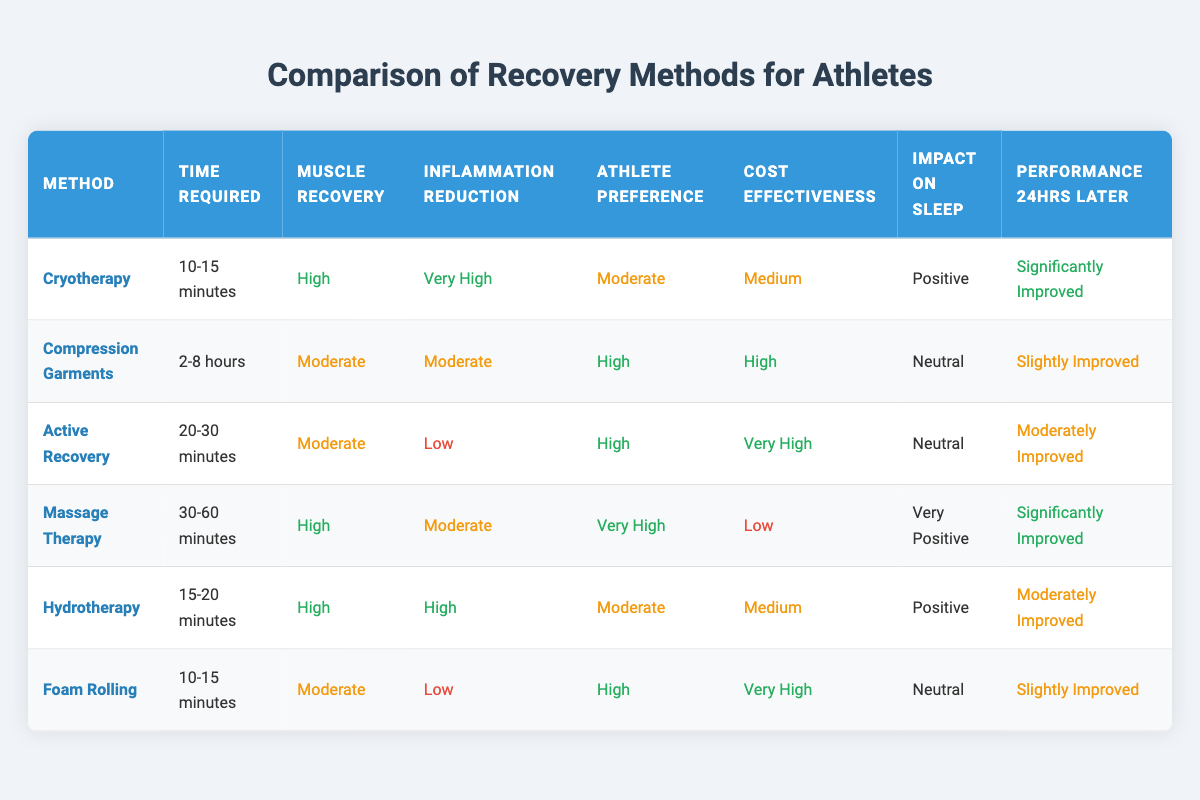What is the time required for Cryotherapy? The table shows the time required for each recovery method in the second column. For Cryotherapy, it states that the time required is "10-15 minutes."
Answer: 10-15 minutes Which recovery method has the highest inflammation reduction? By examining the table, we can see that Cryotherapy has "Very High" listed for inflammation reduction, while no other method surpasses this value.
Answer: Cryotherapy How many recovery methods have a "High" rating for muscle recovery? From the table, both Cryotherapy and Massage Therapy are marked as "High" for muscle recovery. Thus, there are two methods with this rating.
Answer: 2 Is Massage Therapy preferred by athletes? In the table, the athlete preference for Massage Therapy is labeled as "Very High," indicating that athletes do prefer this recovery method.
Answer: Yes Which recovery method provides a slight improvement in performance 24 hours later? The table indicates that Compression Garments and Foam Rolling both yield a "Slightly Improved" performance 24 hours later, confirming that they are the methods associated with this level of improvement.
Answer: Compression Garments and Foam Rolling What is the average time required for all the recovery methods listed? First, we identify the time required in total minutes: Cryotherapy is 12.5 minutes (average of 10-15), Compression Garments (300) minutes, Active Recovery (25 minutes), Massage Therapy (45 minutes), Hydrotherapy (17.5 minutes), and Foam Rolling (12.5 minutes). The overall sum is 12.5 + 300 + 25 + 45 + 17.5 + 12.5 = 412.5 minutes. Dividing by 6 recovery methods gives us an average of 68.75 minutes.
Answer: 68.75 minutes Which method has a "High" cost-effectiveness rating but only a "Moderate" inflammation reduction? The table shows that Compression Garments have a "High" cost-effectiveness rating and "Moderate" for inflammation reduction.
Answer: Compression Garments How does the impact on sleep compare between Massage Therapy and Hydrotherapy? The table indicates that Massage Therapy has a "Very Positive" impact on sleep, while Hydrotherapy has a "Positive" impact. This shows that Massage Therapy is better for sleep improvement than Hydrotherapy.
Answer: Massage Therapy is better for sleep What recovery methods result in "Moderately Improved" performance 24 hours later? From the table, both Hydrotherapy and Active Recovery yield a "Moderately Improved" performance 24 hours later, meaning these two methods are linked to this level of improvement.
Answer: Hydrotherapy and Active Recovery 